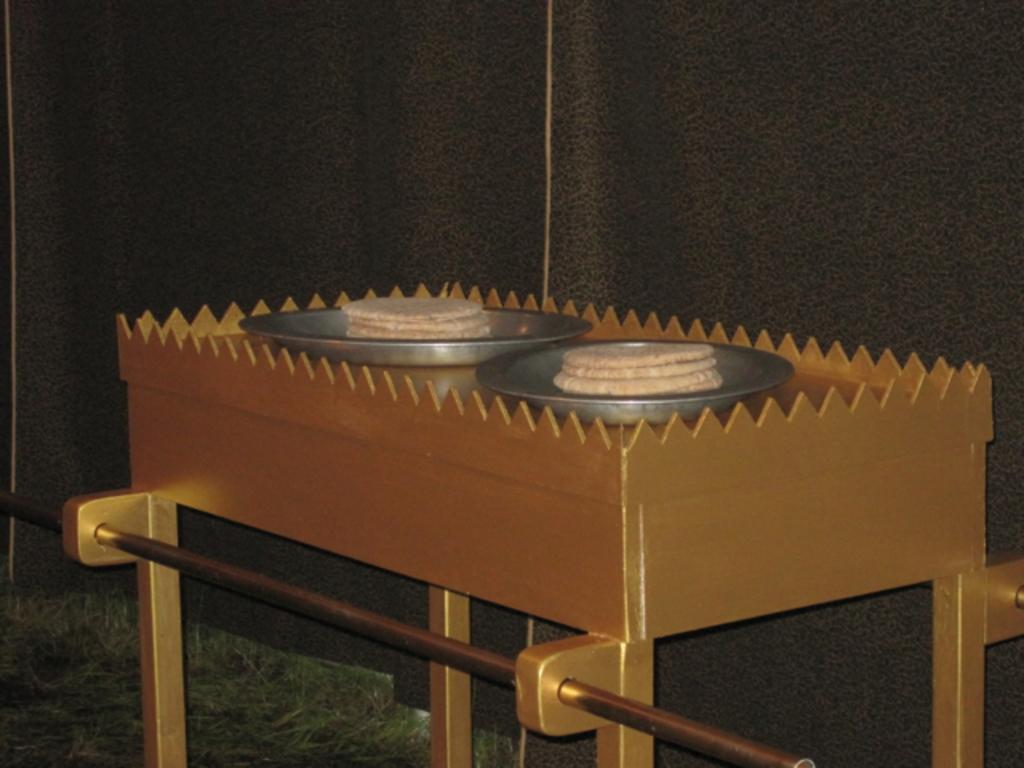What is on the plates that are visible in the image? There are food items on plates in the image. What is the color of the table on which the plates are placed? The plates are placed on a gold-colored table. What type of vegetation can be seen in the image? There is grass visible in the image. How would you describe the lighting in the image? The background of the image is dark. How many grapes can be seen on the table in the image? There is no mention of grapes in the image, so it is impossible to determine how many grapes are present. 